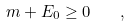<formula> <loc_0><loc_0><loc_500><loc_500>m + E _ { 0 } \geq 0 \quad ,</formula> 